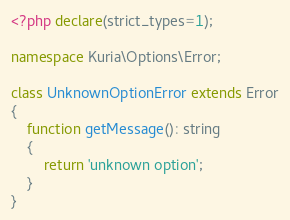<code> <loc_0><loc_0><loc_500><loc_500><_PHP_><?php declare(strict_types=1);

namespace Kuria\Options\Error;

class UnknownOptionError extends Error
{
    function getMessage(): string
    {
        return 'unknown option';
    }
}
</code> 